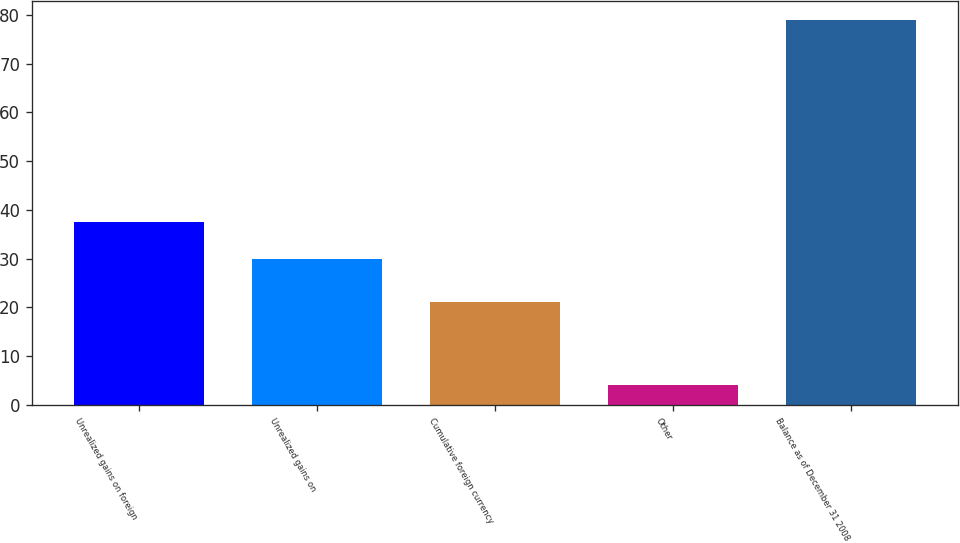Convert chart. <chart><loc_0><loc_0><loc_500><loc_500><bar_chart><fcel>Unrealized gains on foreign<fcel>Unrealized gains on<fcel>Cumulative foreign currency<fcel>Other<fcel>Balance as of December 31 2008<nl><fcel>37.5<fcel>30<fcel>21<fcel>4<fcel>79<nl></chart> 